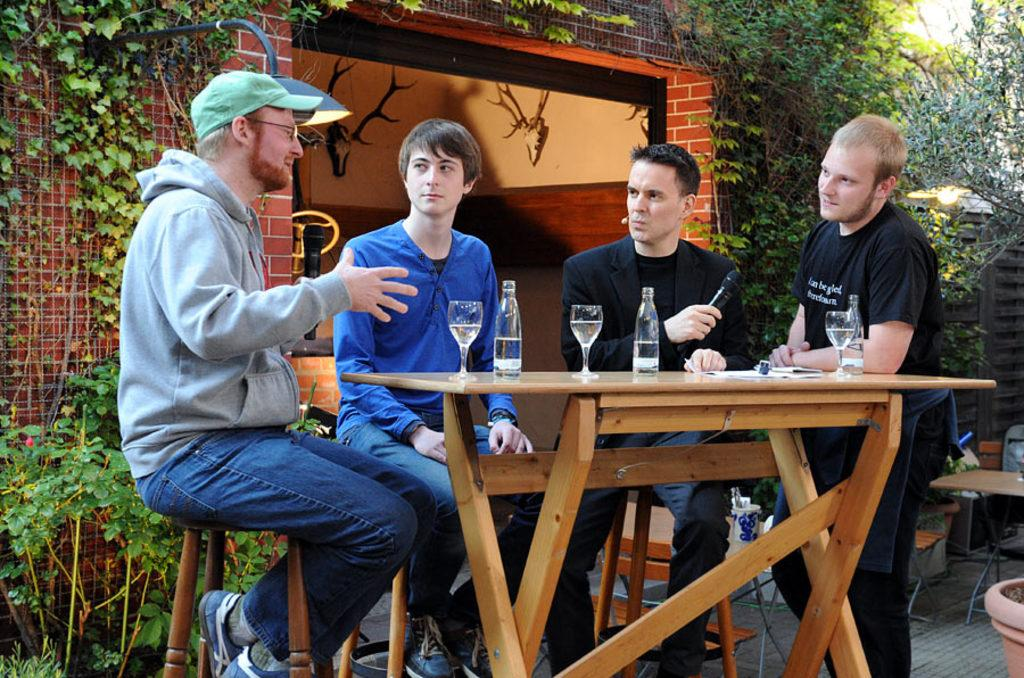How many men are present in the image? There are four men in the image. What are the positions of the men in the image? Three of the men are sitting, and one man is standing. What objects can be seen on the table in the image? There is a bottle and a glass on the table. What type of vegetation is present in the image? There are plants in the image, and a flower pot is also visible. What source of illumination is present in the image? There is a light in the image. What type of pollution can be seen coming from the stove in the image? There is no stove present in the image, and therefore no pollution can be observed. What type of machine is being used by the men in the image? There is no machine being used by the men in the image; they are simply sitting or standing. 